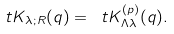<formula> <loc_0><loc_0><loc_500><loc_500>\ t K _ { \lambda ; R } ( q ) = \ t K _ { \Lambda \lambda } ^ { ( p ) } ( q ) .</formula> 